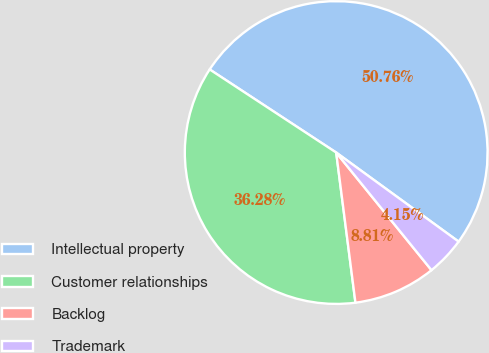Convert chart. <chart><loc_0><loc_0><loc_500><loc_500><pie_chart><fcel>Intellectual property<fcel>Customer relationships<fcel>Backlog<fcel>Trademark<nl><fcel>50.76%<fcel>36.28%<fcel>8.81%<fcel>4.15%<nl></chart> 